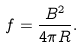Convert formula to latex. <formula><loc_0><loc_0><loc_500><loc_500>f = \frac { B ^ { 2 } } { 4 \pi R } .</formula> 